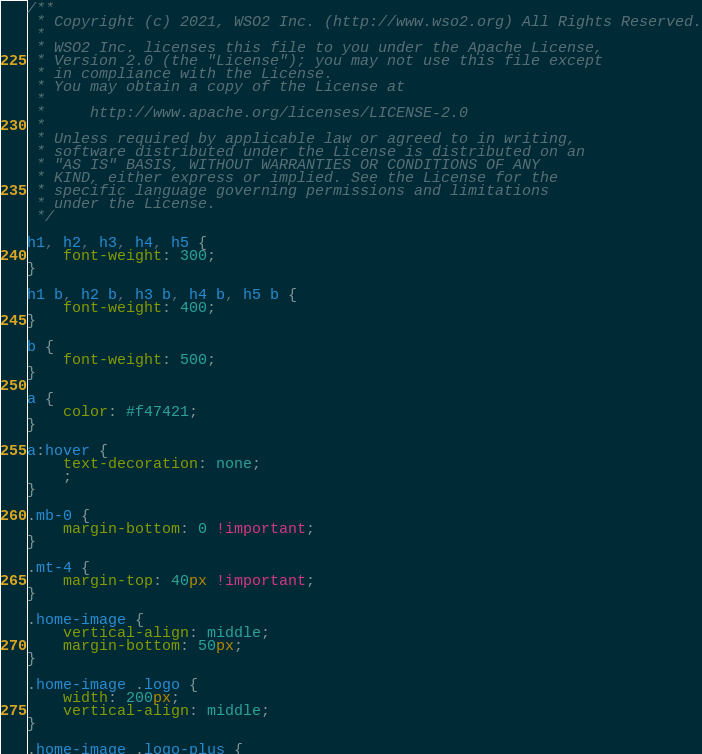Convert code to text. <code><loc_0><loc_0><loc_500><loc_500><_CSS_>/**
 * Copyright (c) 2021, WSO2 Inc. (http://www.wso2.org) All Rights Reserved.
 *
 * WSO2 Inc. licenses this file to you under the Apache License,
 * Version 2.0 (the "License"); you may not use this file except
 * in compliance with the License.
 * You may obtain a copy of the License at
 *
 *     http://www.apache.org/licenses/LICENSE-2.0
 *
 * Unless required by applicable law or agreed to in writing,
 * software distributed under the License is distributed on an
 * "AS IS" BASIS, WITHOUT WARRANTIES OR CONDITIONS OF ANY
 * KIND, either express or implied. See the License for the
 * specific language governing permissions and limitations
 * under the License.
 */

h1, h2, h3, h4, h5 {
    font-weight: 300;
}

h1 b, h2 b, h3 b, h4 b, h5 b {
    font-weight: 400;
}

b {
    font-weight: 500;
}

a {
    color: #f47421;
}

a:hover {
    text-decoration: none;
    ;
}

.mb-0 {
    margin-bottom: 0 !important;
}

.mt-4 {
    margin-top: 40px !important;
}

.home-image {
    vertical-align: middle;
    margin-bottom: 50px;
}

.home-image .logo {
    width: 200px;
    vertical-align: middle;
}

.home-image .logo-plus {</code> 